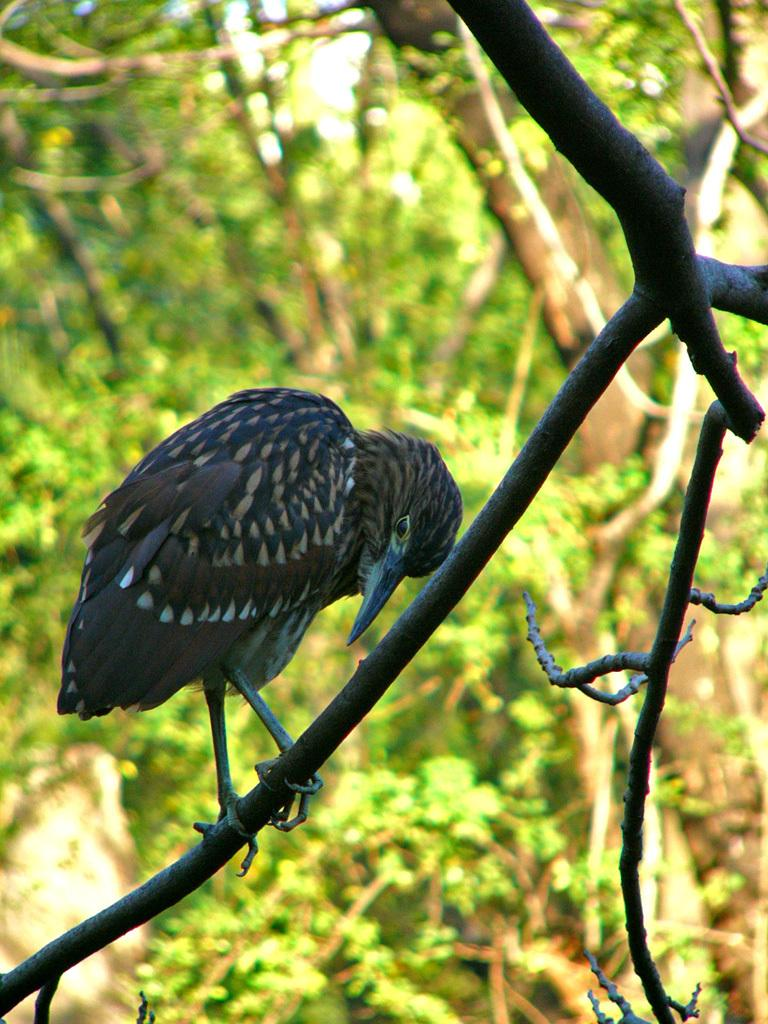What type of animal can be seen in the image? There is a bird in the image. What can be seen in the background of the image? There is a group of trees in the background of the image. How would you describe the background of the image? The background of the image is blurred. What type of paste is being used by the bird in the image? There is no paste present in the image, and the bird is not using any paste. 